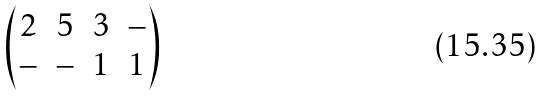<formula> <loc_0><loc_0><loc_500><loc_500>\begin{pmatrix} 2 & 5 & 3 & - \\ - & - & 1 & 1 \end{pmatrix}</formula> 